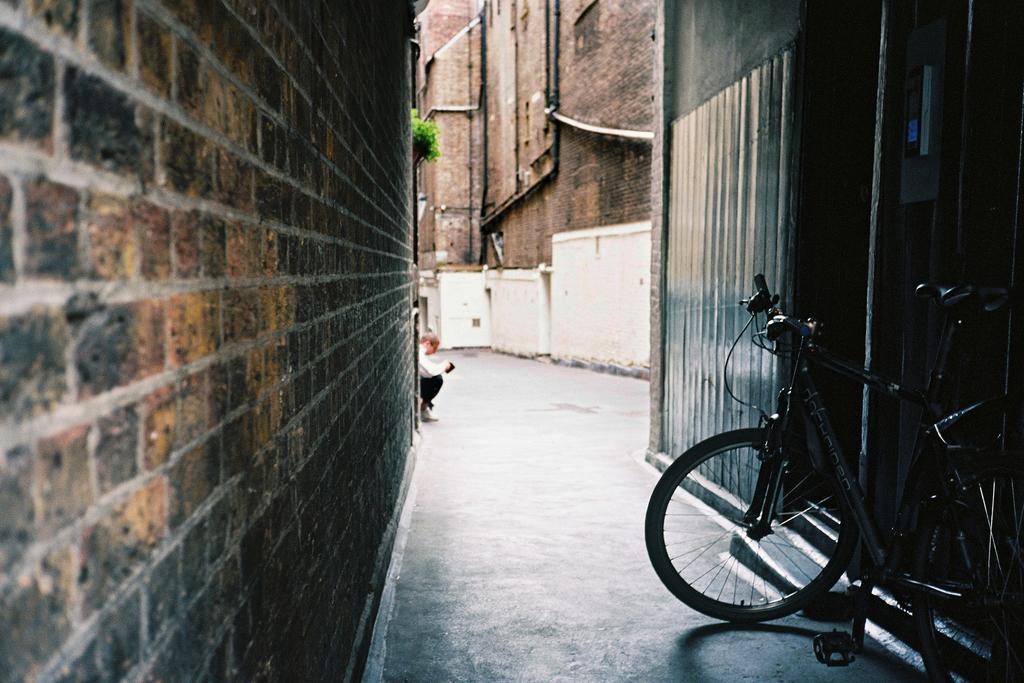How would you summarize this image in a sentence or two? On the right of this picture we can see a bicycle is parked on the ground. On the left we can see the wall. On the right we can see some objects. In the background we can see the brick wall of the building and we can see the green leaves and a person seems to be squatting on the ground and we can see the metal rods and some objects. In the foreground we can see the ground. 